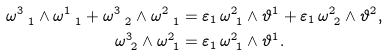<formula> <loc_0><loc_0><loc_500><loc_500>\omega ^ { 3 } _ { \ 1 } \wedge \omega ^ { 1 } _ { \ 1 } + \omega ^ { 3 } _ { \ 2 } \wedge \omega ^ { 2 } _ { \ 1 } & = \varepsilon _ { 1 } \, \omega ^ { 2 } _ { \ 1 } \wedge \vartheta ^ { 1 } + \varepsilon _ { 1 } \, \omega ^ { 2 } _ { \ 2 } \wedge \vartheta ^ { 2 } , \\ \omega ^ { 3 } _ { \ 2 } \wedge \omega ^ { 2 } _ { \ 1 } & = \varepsilon _ { 1 } \, \omega ^ { 2 } _ { \ 1 } \wedge \vartheta ^ { 1 } .</formula> 